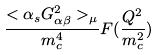Convert formula to latex. <formula><loc_0><loc_0><loc_500><loc_500>\frac { < \alpha _ { s } G _ { \alpha \beta } ^ { 2 } > _ { \mu } } { m _ { c } ^ { 4 } } F ( \frac { Q ^ { 2 } } { m _ { c } ^ { 2 } } )</formula> 